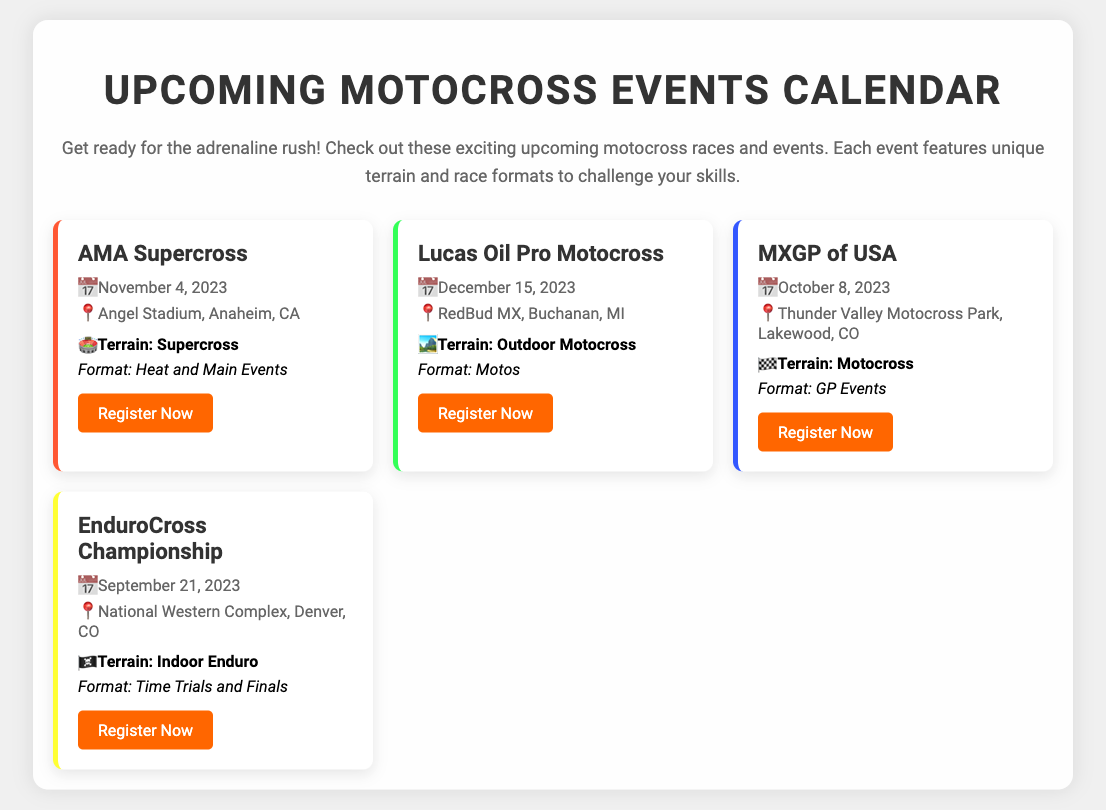What date is the AMA Supercross scheduled? The date for the AMA Supercross is highlighted in the event details section.
Answer: November 4, 2023 Where is the Lucas Oil Pro Motocross held? The location of Lucas Oil Pro Motocross is provided in the event details.
Answer: RedBud MX, Buchanan, MI What type of terrain is used in the MXGP of USA? The terrain type is specified in the event terrain section.
Answer: Motocross What is the format of the EnduroCross Championship? The format details can be found in the event format section.
Answer: Time Trials and Finals How many events are listed in the document? Counting the event cards provides the total number of events included in the calendar.
Answer: 4 What color is used for the terrain in the Lucas Oil Pro Motocross event card? The event card has a specific colored left border indicating the terrain type.
Answer: Green Which event takes place in Denver, CO? The location mentioned in the event details will lead to the correct event.
Answer: EnduroCross Championship When is the registration for the MXGP of USA? The registration details are contained within the event card for MXGP of USA.
Answer: Register Now (link context) 